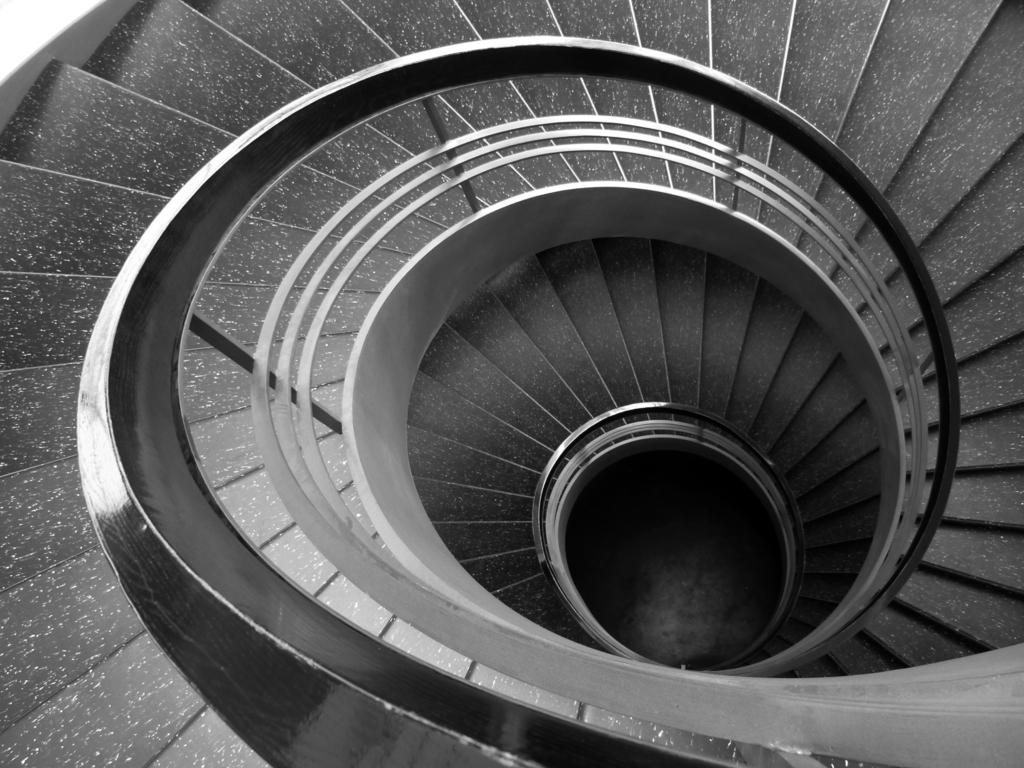What type of structure is present in the image? There is a staircase in the image. What feature is present along the staircase? The staircase has railing. How many lamps are needed to illuminate the staircase in the image? There is no information about lamps in the image, so we cannot determine how many are needed. 